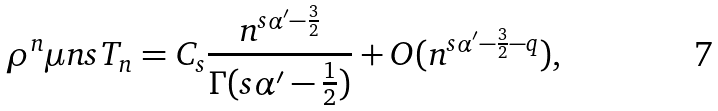Convert formula to latex. <formula><loc_0><loc_0><loc_500><loc_500>\rho ^ { n } \mu n { s } T _ { n } = C _ { s } \frac { n ^ { s \alpha ^ { \prime } - \frac { 3 } { 2 } } } { \Gamma ( s \alpha ^ { \prime } - \frac { 1 } { 2 } ) } + O ( n ^ { s \alpha ^ { \prime } - \frac { 3 } { 2 } - q } ) ,</formula> 